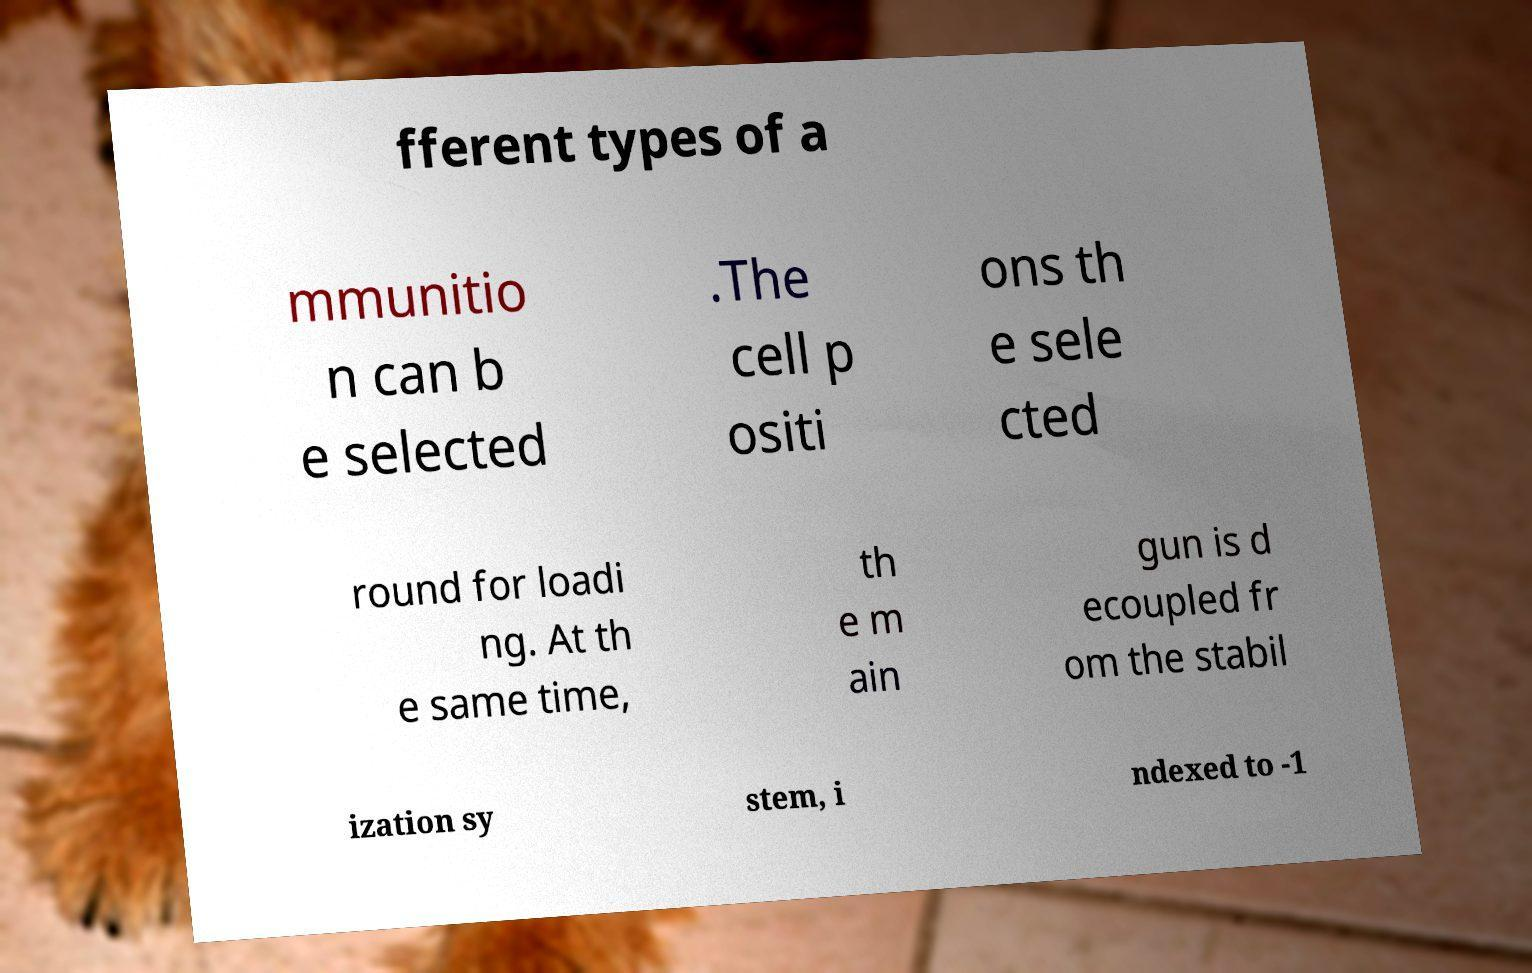Please read and relay the text visible in this image. What does it say? fferent types of a mmunitio n can b e selected .The cell p ositi ons th e sele cted round for loadi ng. At th e same time, th e m ain gun is d ecoupled fr om the stabil ization sy stem, i ndexed to -1 